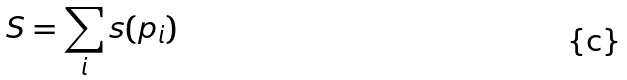<formula> <loc_0><loc_0><loc_500><loc_500>S = \sum _ { i } s ( p _ { i } )</formula> 